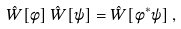<formula> <loc_0><loc_0><loc_500><loc_500>\hat { W } [ \phi ] \, \hat { W } [ \psi ] = \hat { W } [ \phi ^ { * } \psi ] \, ,</formula> 